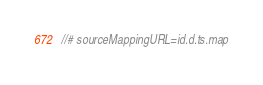<code> <loc_0><loc_0><loc_500><loc_500><_TypeScript_>//# sourceMappingURL=id.d.ts.map</code> 